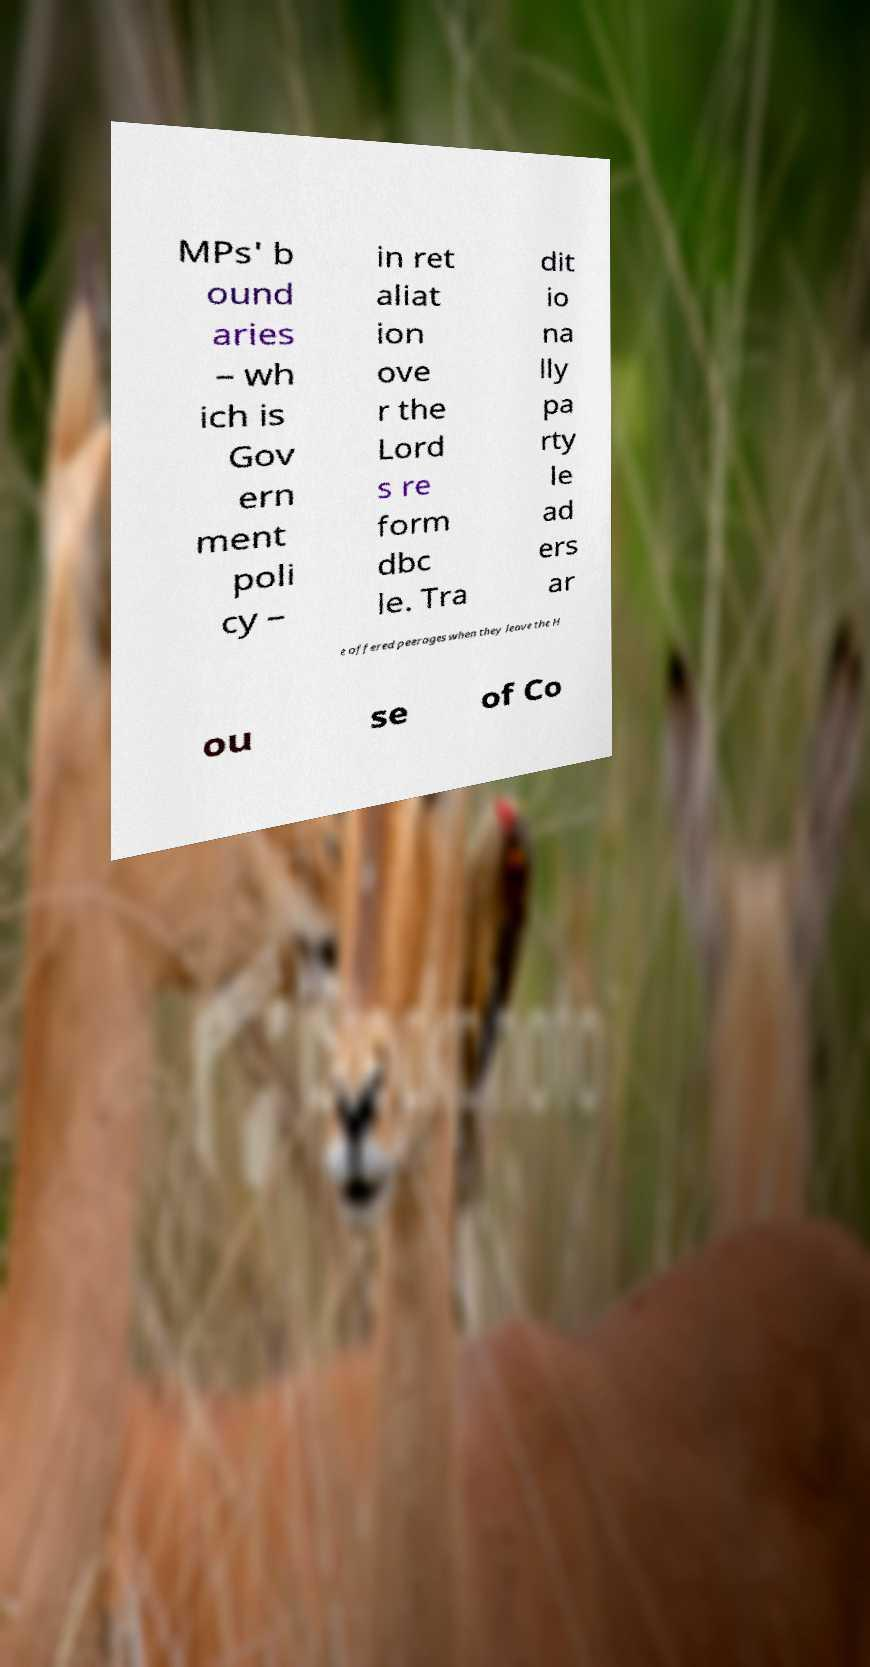Can you accurately transcribe the text from the provided image for me? MPs' b ound aries – wh ich is Gov ern ment poli cy – in ret aliat ion ove r the Lord s re form dbc le. Tra dit io na lly pa rty le ad ers ar e offered peerages when they leave the H ou se of Co 